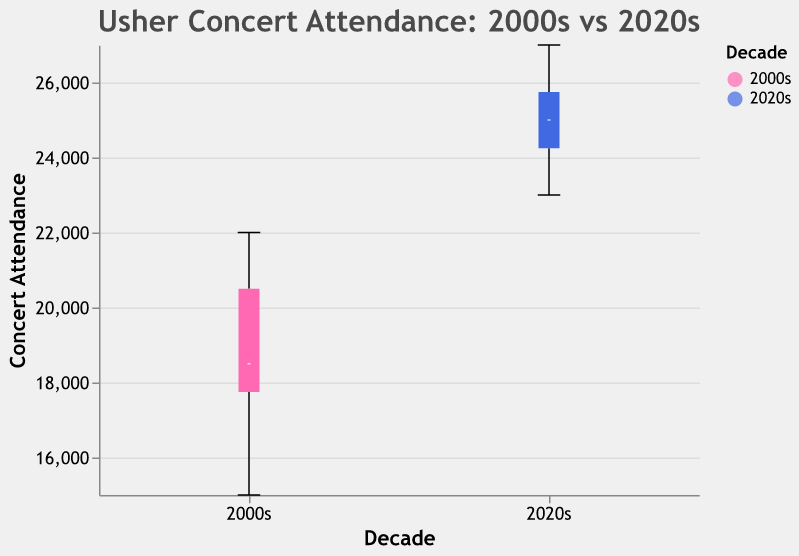How many categories (decades) are represented in the box plot? The box plot shows distinct categories on the x-axis labeled as "Decade." There are two groupings shown in the plot: the "2000s" and the "2020s."
Answer: 2 What is the highest concert attendance in the 2000s? Look at the top of the box plot for the 2000s category; the highest whisker value shows the maximum concert attendance. The highest value in the 2000s appears to be 22,000.
Answer: 22,000 What is the median concert attendance in the 2020s? Look at the median line inside the box for the 2020s category, which indicates the median concert attendance. The median value seems to be approximately 24,500.
Answer: 24,500 Which decade shows a greater range in concert attendance? Calculate the range by subtracting the minimum value from the maximum value for both decades. The 2000s have an attendance range from 15,000 to 22,000, and the 2020s range from 23,000 to 27,000. The range for the 2020s (27,000 - 23,000 = 4,000) is larger than the 2000s (22,000 - 15,000 = 7,000).
Answer: 2000s What is the interquartile range (IQR) for the 2020s? The IQR is the difference between the third quartile (Q3) and the first quartile (Q1). The box in a box plot represents the IQR. In the 2020s, the lower quartile is around 24,000 and the upper quartile is approximately 26,000. The IQR is 26,000 - 24,000 = 2,000.
Answer: 2,000 Is the median concert attendance higher in the 2020s or the 2000s? Compare the middle lines inside each box. The median in the 2020s (around 24,500) is higher than the median in the 2000s (around 19,000).
Answer: 2020s What’s the difference between the highest attendance in the 2020s and 2000s? Subtract the highest attendance in the 2000s from the highest attendance in the 2020s. Maximum attendance in the 2020s is 27,000, and in the 2000s, it is 22,000. So, 27,000 - 22,000 = 5,000.
Answer: 5,000 Does any decade have outliers in concert attendance? Outliers are typically shown as individual points outside the whiskers of the box plot. By examining the plot, it doesn't appear there are any outliers in either the 2000s or 2020s.
Answer: No 